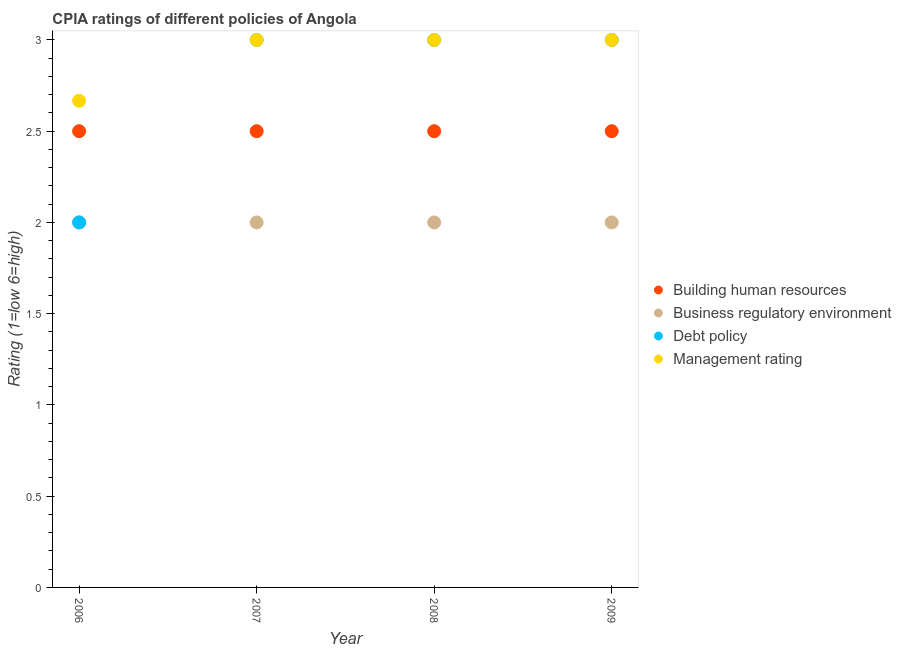How many different coloured dotlines are there?
Make the answer very short. 4. Is the number of dotlines equal to the number of legend labels?
Make the answer very short. Yes. What is the cpia rating of building human resources in 2009?
Your answer should be very brief. 2.5. Across all years, what is the minimum cpia rating of debt policy?
Provide a succinct answer. 2. In which year was the cpia rating of management minimum?
Provide a succinct answer. 2006. What is the total cpia rating of building human resources in the graph?
Offer a terse response. 10. What is the difference between the cpia rating of debt policy in 2008 and that in 2009?
Give a very brief answer. 0. What is the average cpia rating of building human resources per year?
Provide a short and direct response. 2.5. What is the ratio of the cpia rating of business regulatory environment in 2007 to that in 2008?
Make the answer very short. 1. What is the difference between the highest and the second highest cpia rating of building human resources?
Offer a terse response. 0. What is the difference between the highest and the lowest cpia rating of debt policy?
Make the answer very short. 1. In how many years, is the cpia rating of business regulatory environment greater than the average cpia rating of business regulatory environment taken over all years?
Ensure brevity in your answer.  0. Is it the case that in every year, the sum of the cpia rating of management and cpia rating of building human resources is greater than the sum of cpia rating of debt policy and cpia rating of business regulatory environment?
Offer a terse response. No. Is the cpia rating of management strictly greater than the cpia rating of building human resources over the years?
Your response must be concise. Yes. Does the graph contain grids?
Give a very brief answer. No. How are the legend labels stacked?
Provide a short and direct response. Vertical. What is the title of the graph?
Your answer should be very brief. CPIA ratings of different policies of Angola. What is the Rating (1=low 6=high) in Building human resources in 2006?
Provide a short and direct response. 2.5. What is the Rating (1=low 6=high) in Management rating in 2006?
Provide a succinct answer. 2.67. What is the Rating (1=low 6=high) of Building human resources in 2007?
Your response must be concise. 2.5. What is the Rating (1=low 6=high) in Debt policy in 2007?
Your answer should be compact. 3. What is the Rating (1=low 6=high) in Business regulatory environment in 2008?
Give a very brief answer. 2. What is the Rating (1=low 6=high) of Management rating in 2009?
Offer a terse response. 3. Across all years, what is the maximum Rating (1=low 6=high) of Business regulatory environment?
Offer a terse response. 2. Across all years, what is the maximum Rating (1=low 6=high) in Debt policy?
Provide a succinct answer. 3. Across all years, what is the minimum Rating (1=low 6=high) in Business regulatory environment?
Provide a succinct answer. 2. Across all years, what is the minimum Rating (1=low 6=high) in Debt policy?
Keep it short and to the point. 2. Across all years, what is the minimum Rating (1=low 6=high) in Management rating?
Your response must be concise. 2.67. What is the total Rating (1=low 6=high) of Building human resources in the graph?
Provide a short and direct response. 10. What is the total Rating (1=low 6=high) in Business regulatory environment in the graph?
Offer a terse response. 8. What is the total Rating (1=low 6=high) in Debt policy in the graph?
Your answer should be very brief. 11. What is the total Rating (1=low 6=high) in Management rating in the graph?
Your answer should be compact. 11.67. What is the difference between the Rating (1=low 6=high) of Building human resources in 2006 and that in 2007?
Your answer should be compact. 0. What is the difference between the Rating (1=low 6=high) of Debt policy in 2006 and that in 2007?
Make the answer very short. -1. What is the difference between the Rating (1=low 6=high) in Management rating in 2006 and that in 2007?
Your answer should be very brief. -0.33. What is the difference between the Rating (1=low 6=high) in Debt policy in 2006 and that in 2008?
Keep it short and to the point. -1. What is the difference between the Rating (1=low 6=high) in Management rating in 2006 and that in 2008?
Keep it short and to the point. -0.33. What is the difference between the Rating (1=low 6=high) of Business regulatory environment in 2006 and that in 2009?
Provide a short and direct response. 0. What is the difference between the Rating (1=low 6=high) of Debt policy in 2006 and that in 2009?
Offer a terse response. -1. What is the difference between the Rating (1=low 6=high) of Building human resources in 2007 and that in 2008?
Ensure brevity in your answer.  0. What is the difference between the Rating (1=low 6=high) in Management rating in 2007 and that in 2008?
Your answer should be compact. 0. What is the difference between the Rating (1=low 6=high) in Building human resources in 2007 and that in 2009?
Your answer should be compact. 0. What is the difference between the Rating (1=low 6=high) of Debt policy in 2007 and that in 2009?
Give a very brief answer. 0. What is the difference between the Rating (1=low 6=high) of Management rating in 2007 and that in 2009?
Give a very brief answer. 0. What is the difference between the Rating (1=low 6=high) of Building human resources in 2008 and that in 2009?
Provide a short and direct response. 0. What is the difference between the Rating (1=low 6=high) of Business regulatory environment in 2008 and that in 2009?
Your answer should be compact. 0. What is the difference between the Rating (1=low 6=high) in Management rating in 2008 and that in 2009?
Provide a succinct answer. 0. What is the difference between the Rating (1=low 6=high) of Building human resources in 2006 and the Rating (1=low 6=high) of Business regulatory environment in 2007?
Ensure brevity in your answer.  0.5. What is the difference between the Rating (1=low 6=high) of Building human resources in 2006 and the Rating (1=low 6=high) of Management rating in 2007?
Your answer should be very brief. -0.5. What is the difference between the Rating (1=low 6=high) in Business regulatory environment in 2006 and the Rating (1=low 6=high) in Management rating in 2007?
Make the answer very short. -1. What is the difference between the Rating (1=low 6=high) in Debt policy in 2006 and the Rating (1=low 6=high) in Management rating in 2007?
Offer a terse response. -1. What is the difference between the Rating (1=low 6=high) in Building human resources in 2006 and the Rating (1=low 6=high) in Management rating in 2008?
Offer a terse response. -0.5. What is the difference between the Rating (1=low 6=high) in Debt policy in 2006 and the Rating (1=low 6=high) in Management rating in 2008?
Keep it short and to the point. -1. What is the difference between the Rating (1=low 6=high) of Building human resources in 2006 and the Rating (1=low 6=high) of Business regulatory environment in 2009?
Your response must be concise. 0.5. What is the difference between the Rating (1=low 6=high) in Building human resources in 2006 and the Rating (1=low 6=high) in Management rating in 2009?
Your answer should be compact. -0.5. What is the difference between the Rating (1=low 6=high) in Building human resources in 2007 and the Rating (1=low 6=high) in Management rating in 2008?
Your answer should be compact. -0.5. What is the difference between the Rating (1=low 6=high) of Building human resources in 2007 and the Rating (1=low 6=high) of Debt policy in 2009?
Keep it short and to the point. -0.5. What is the difference between the Rating (1=low 6=high) of Building human resources in 2007 and the Rating (1=low 6=high) of Management rating in 2009?
Ensure brevity in your answer.  -0.5. What is the difference between the Rating (1=low 6=high) of Business regulatory environment in 2007 and the Rating (1=low 6=high) of Debt policy in 2009?
Provide a succinct answer. -1. What is the difference between the Rating (1=low 6=high) of Building human resources in 2008 and the Rating (1=low 6=high) of Business regulatory environment in 2009?
Make the answer very short. 0.5. What is the difference between the Rating (1=low 6=high) in Building human resources in 2008 and the Rating (1=low 6=high) in Management rating in 2009?
Ensure brevity in your answer.  -0.5. What is the difference between the Rating (1=low 6=high) in Business regulatory environment in 2008 and the Rating (1=low 6=high) in Debt policy in 2009?
Your answer should be very brief. -1. What is the difference between the Rating (1=low 6=high) in Business regulatory environment in 2008 and the Rating (1=low 6=high) in Management rating in 2009?
Keep it short and to the point. -1. What is the average Rating (1=low 6=high) in Building human resources per year?
Your response must be concise. 2.5. What is the average Rating (1=low 6=high) of Business regulatory environment per year?
Your response must be concise. 2. What is the average Rating (1=low 6=high) in Debt policy per year?
Provide a succinct answer. 2.75. What is the average Rating (1=low 6=high) of Management rating per year?
Offer a terse response. 2.92. In the year 2006, what is the difference between the Rating (1=low 6=high) of Building human resources and Rating (1=low 6=high) of Debt policy?
Provide a short and direct response. 0.5. In the year 2006, what is the difference between the Rating (1=low 6=high) in Building human resources and Rating (1=low 6=high) in Management rating?
Ensure brevity in your answer.  -0.17. In the year 2006, what is the difference between the Rating (1=low 6=high) of Business regulatory environment and Rating (1=low 6=high) of Debt policy?
Your answer should be very brief. 0. In the year 2006, what is the difference between the Rating (1=low 6=high) in Debt policy and Rating (1=low 6=high) in Management rating?
Give a very brief answer. -0.67. In the year 2007, what is the difference between the Rating (1=low 6=high) in Building human resources and Rating (1=low 6=high) in Debt policy?
Offer a very short reply. -0.5. In the year 2007, what is the difference between the Rating (1=low 6=high) in Building human resources and Rating (1=low 6=high) in Management rating?
Make the answer very short. -0.5. In the year 2007, what is the difference between the Rating (1=low 6=high) of Business regulatory environment and Rating (1=low 6=high) of Debt policy?
Provide a short and direct response. -1. In the year 2007, what is the difference between the Rating (1=low 6=high) of Debt policy and Rating (1=low 6=high) of Management rating?
Ensure brevity in your answer.  0. In the year 2008, what is the difference between the Rating (1=low 6=high) of Building human resources and Rating (1=low 6=high) of Business regulatory environment?
Your answer should be very brief. 0.5. In the year 2008, what is the difference between the Rating (1=low 6=high) in Building human resources and Rating (1=low 6=high) in Debt policy?
Your response must be concise. -0.5. In the year 2008, what is the difference between the Rating (1=low 6=high) of Debt policy and Rating (1=low 6=high) of Management rating?
Ensure brevity in your answer.  0. In the year 2009, what is the difference between the Rating (1=low 6=high) in Building human resources and Rating (1=low 6=high) in Business regulatory environment?
Your answer should be very brief. 0.5. In the year 2009, what is the difference between the Rating (1=low 6=high) of Business regulatory environment and Rating (1=low 6=high) of Debt policy?
Your response must be concise. -1. In the year 2009, what is the difference between the Rating (1=low 6=high) of Business regulatory environment and Rating (1=low 6=high) of Management rating?
Provide a succinct answer. -1. In the year 2009, what is the difference between the Rating (1=low 6=high) of Debt policy and Rating (1=low 6=high) of Management rating?
Give a very brief answer. 0. What is the ratio of the Rating (1=low 6=high) in Building human resources in 2006 to that in 2007?
Offer a very short reply. 1. What is the ratio of the Rating (1=low 6=high) of Management rating in 2006 to that in 2007?
Offer a very short reply. 0.89. What is the ratio of the Rating (1=low 6=high) of Business regulatory environment in 2006 to that in 2008?
Offer a terse response. 1. What is the ratio of the Rating (1=low 6=high) in Debt policy in 2006 to that in 2008?
Your answer should be compact. 0.67. What is the ratio of the Rating (1=low 6=high) of Debt policy in 2006 to that in 2009?
Your response must be concise. 0.67. What is the ratio of the Rating (1=low 6=high) in Management rating in 2006 to that in 2009?
Make the answer very short. 0.89. What is the ratio of the Rating (1=low 6=high) in Building human resources in 2007 to that in 2008?
Offer a terse response. 1. What is the ratio of the Rating (1=low 6=high) in Business regulatory environment in 2007 to that in 2008?
Keep it short and to the point. 1. What is the ratio of the Rating (1=low 6=high) in Debt policy in 2007 to that in 2008?
Offer a very short reply. 1. What is the ratio of the Rating (1=low 6=high) in Debt policy in 2007 to that in 2009?
Provide a succinct answer. 1. What is the ratio of the Rating (1=low 6=high) in Business regulatory environment in 2008 to that in 2009?
Provide a succinct answer. 1. What is the difference between the highest and the second highest Rating (1=low 6=high) of Business regulatory environment?
Provide a short and direct response. 0. What is the difference between the highest and the second highest Rating (1=low 6=high) in Management rating?
Give a very brief answer. 0. What is the difference between the highest and the lowest Rating (1=low 6=high) in Building human resources?
Give a very brief answer. 0. What is the difference between the highest and the lowest Rating (1=low 6=high) of Business regulatory environment?
Give a very brief answer. 0. What is the difference between the highest and the lowest Rating (1=low 6=high) of Management rating?
Provide a succinct answer. 0.33. 